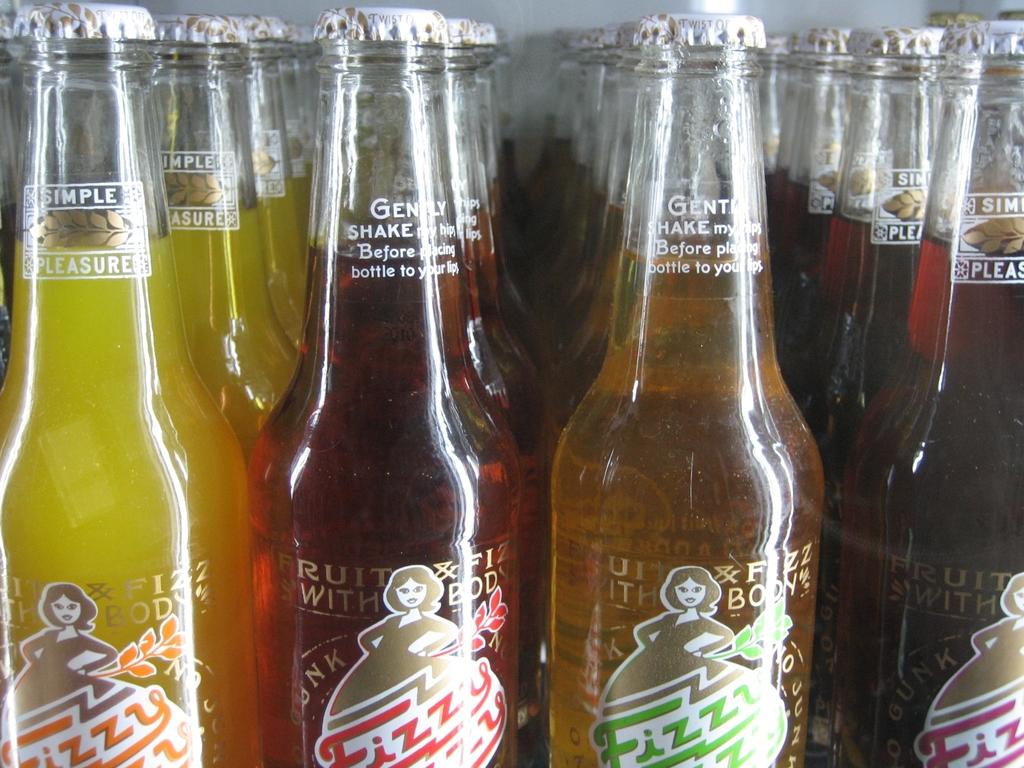What must one do before placing the bottle to their lips?
Your response must be concise. Gently shake. What kind of pleasure does the yellow bottle give?
Offer a very short reply. Simple. 